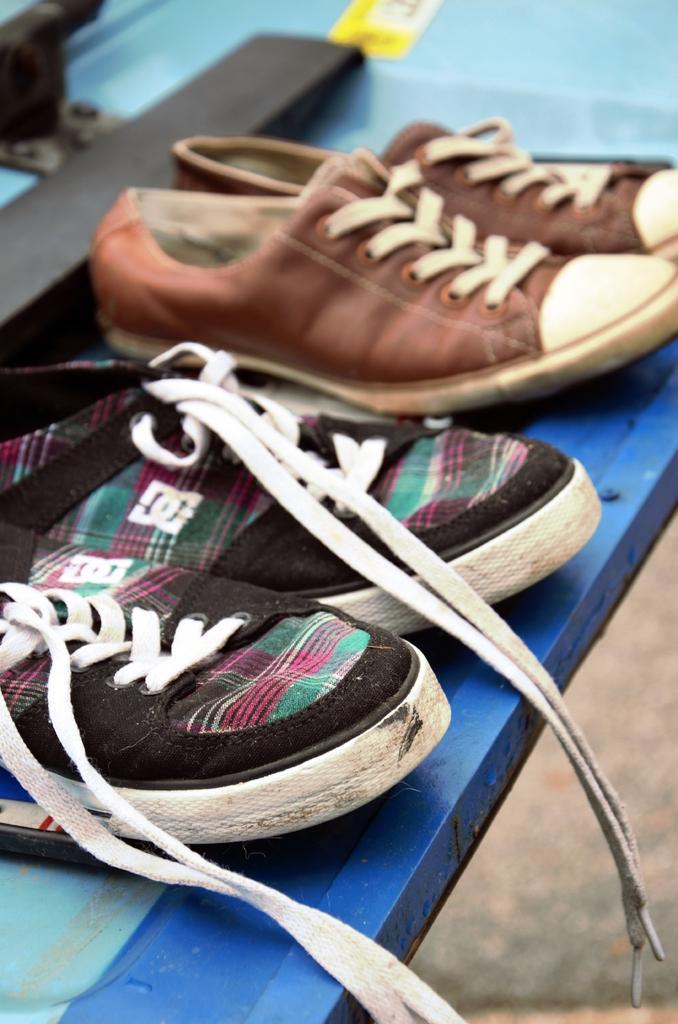Describe this image in one or two sentences. In the center of the image we can see one table. On the table, we can see two pairs of shoes, which are in different colors. and we can see one black color object and a few other objects. 